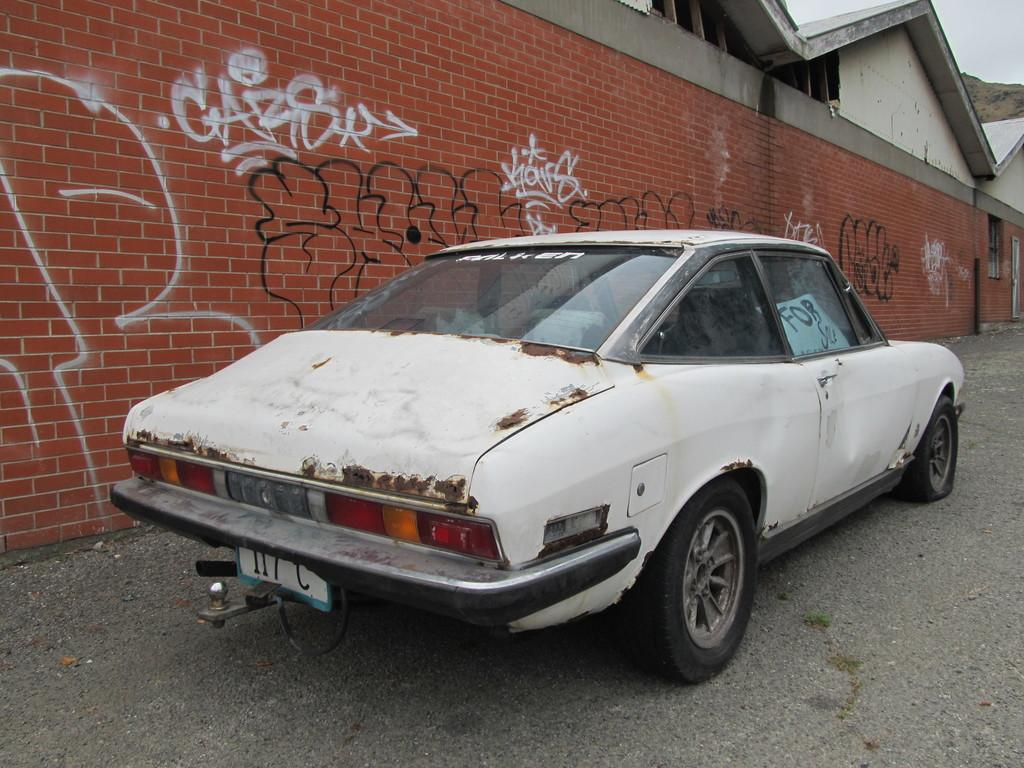What type of vehicle is on the road in the image? There is a white color car on the road in the image. What can be seen on the wall in the image? There is graffiti on a wall in the image. What structures are present in the image? There are buildings in the image. What natural feature is visible in the image? There is a hill visible in the image. What is visible above the structures and natural features in the image? The sky is visible in the image. What type of agreement is being discussed in the image? There is no indication of any agreement being discussed in the image. Can you hear the current in the image? There is no audible sound in the image, so it is not possible to hear the current. 